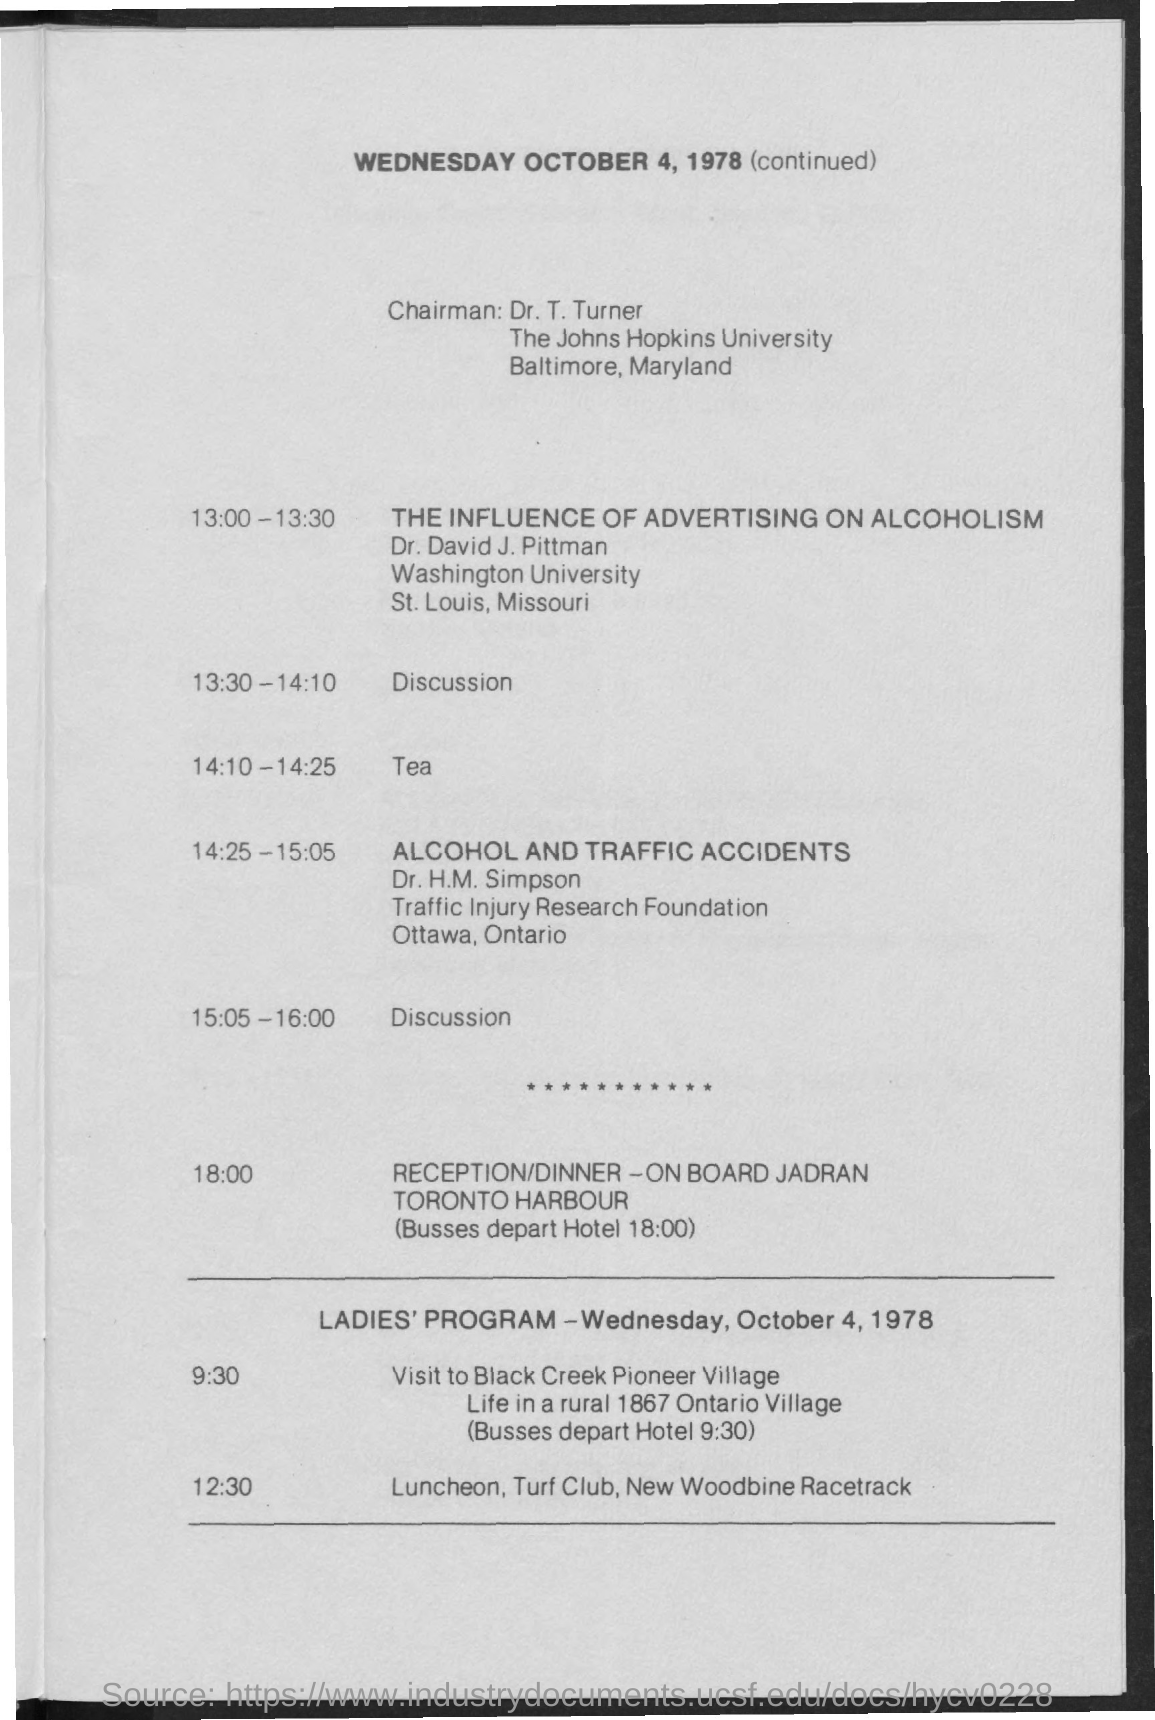Who is the Chairman?
Your answer should be very brief. Dr. t. turner. Which day's schedule is this?
Offer a terse response. October 4, 1978. When is the reception/dinner?
Provide a short and direct response. 18:00. Where is the reception/dinner?
Your answer should be very brief. On board Jadran toronto harbour. 